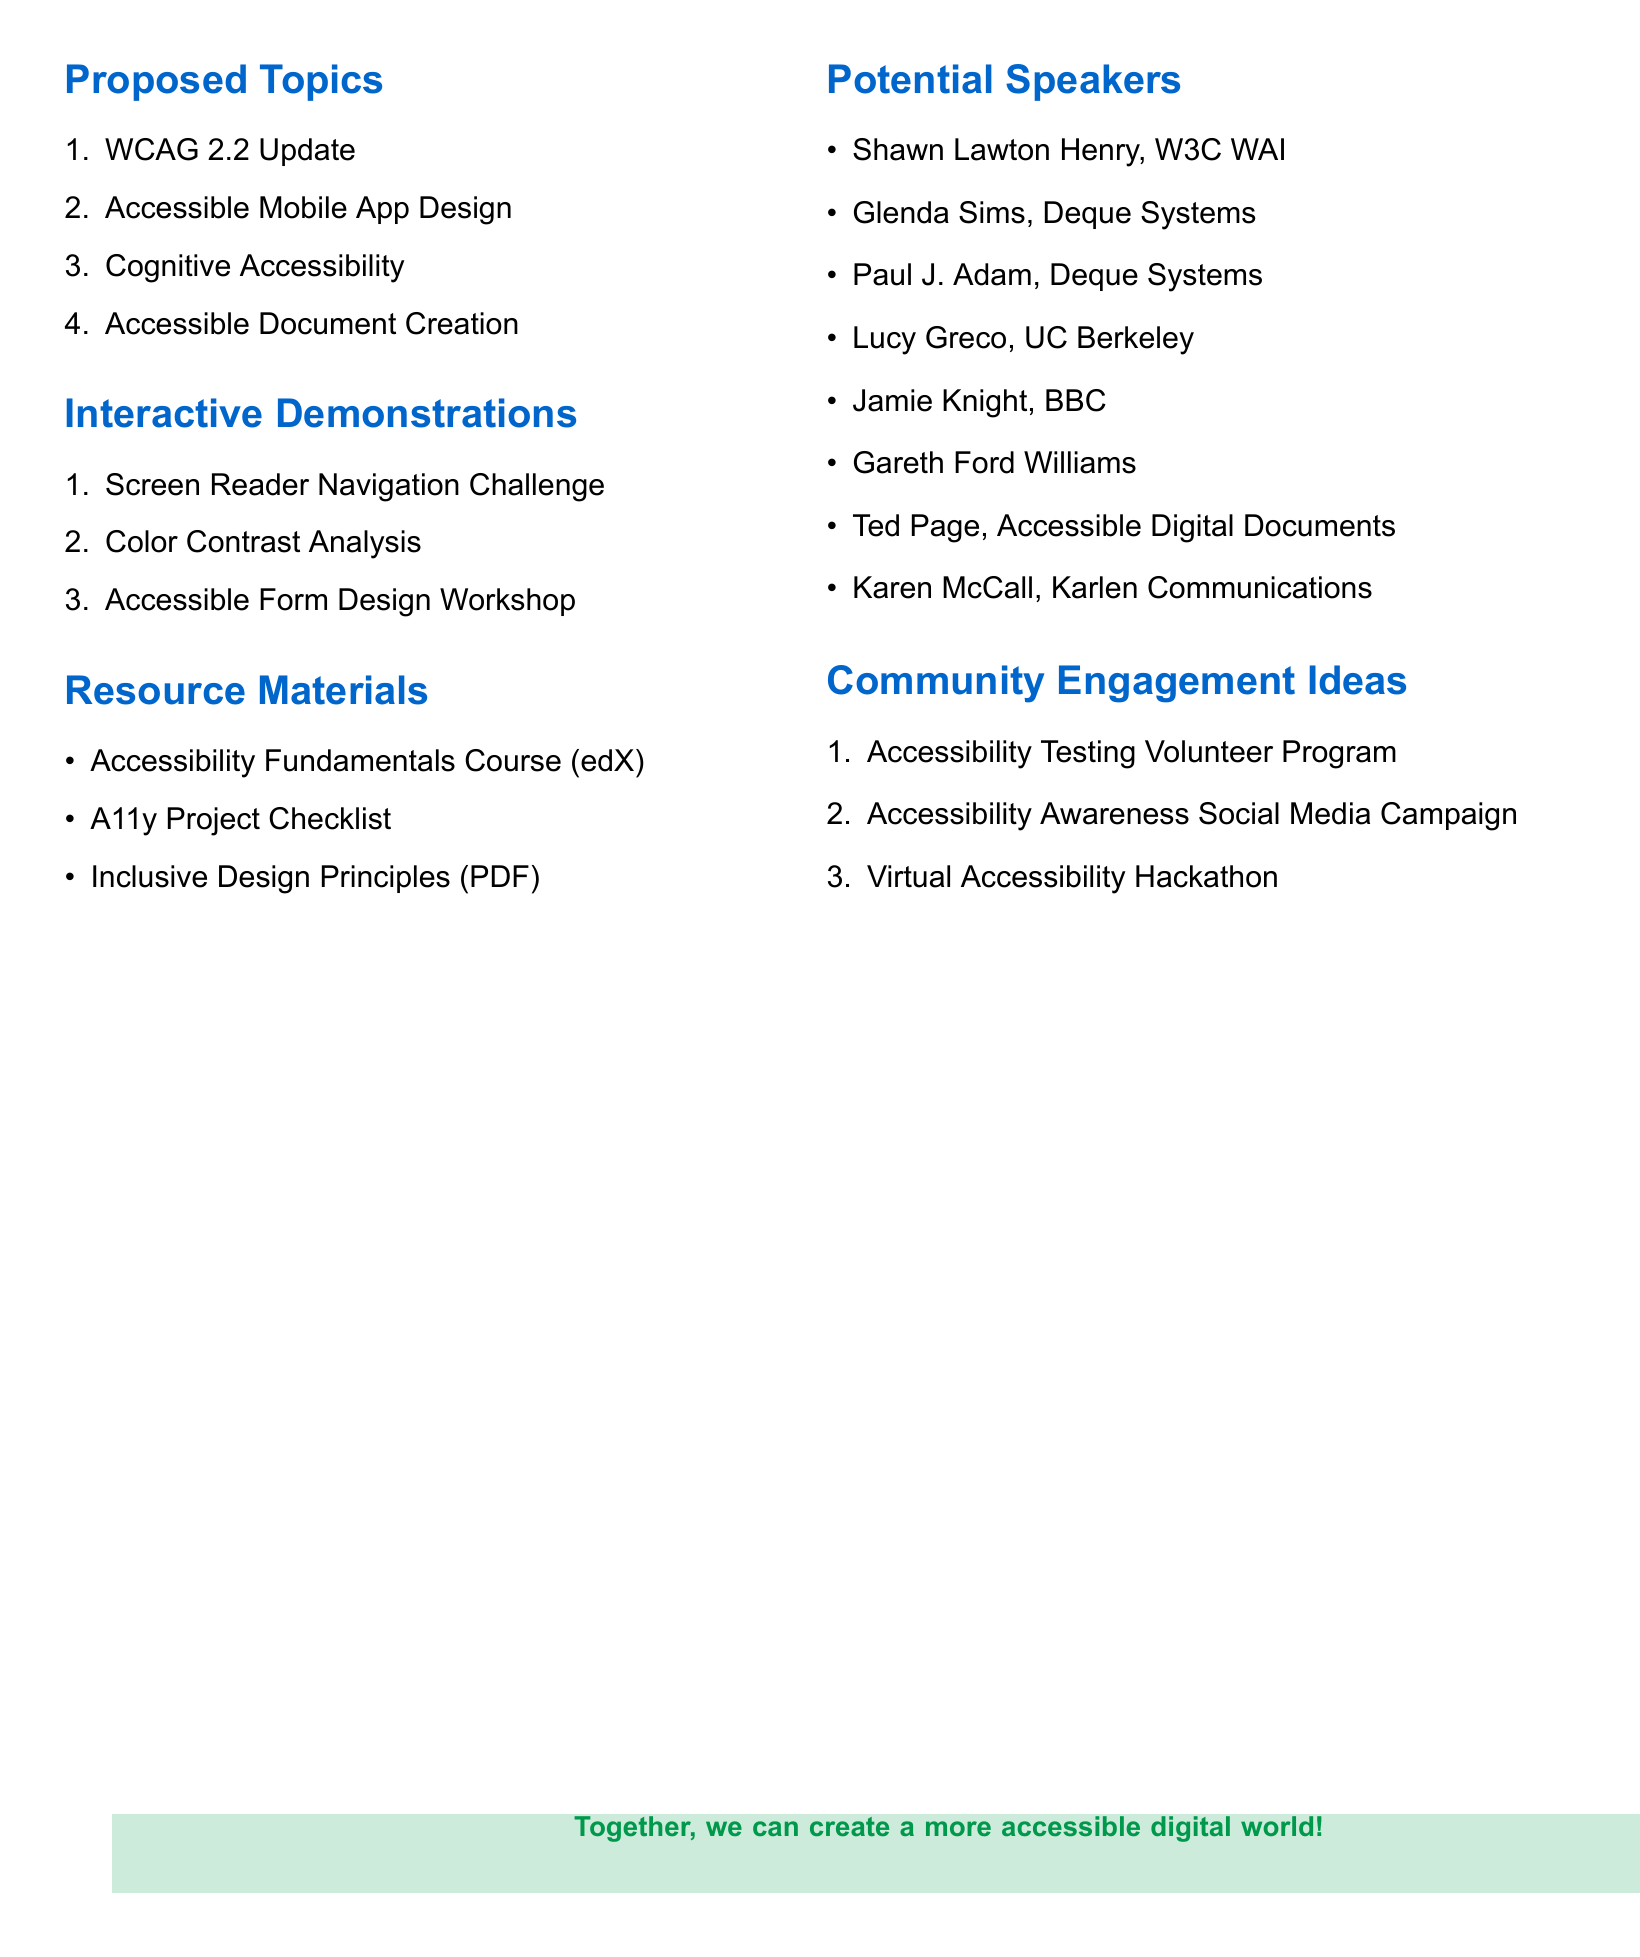What is the date of the planning session? The date is explicitly stated in the document where it lists the planning session details.
Answer: June 15, 2023 What is the name of the first proposed topic? The first proposed topic is the first item listed in the Proposed Topics section.
Answer: Web Content Accessibility Guidelines (WCAG) 2.2 Update Who are the potential speakers for the second proposed topic? Potential speakers can be found under each proposed topic, specifically for "Accessible Mobile App Design."
Answer: Paul J. Adam, Lucy Greco How many interactive demonstrations are proposed? The number is total items listed in the Interactive Demonstrations section.
Answer: Three What resource format is the "A11y Project Checklist"? The format is described in the Resource Materials section.
Answer: Web resource What is one of the community engagement ideas? Community engagement ideas are listed in their own section, and any of the items listed qualifies as an answer.
Answer: Accessibility Testing Volunteer Program What time is the planning session scheduled to start? The starting time is provided in the planning session details.
Answer: 10:00 AM Who is providing the Accessibility Fundamentals Course? The provider is mentioned alongside the course title in the Resource Materials section.
Answer: edX 